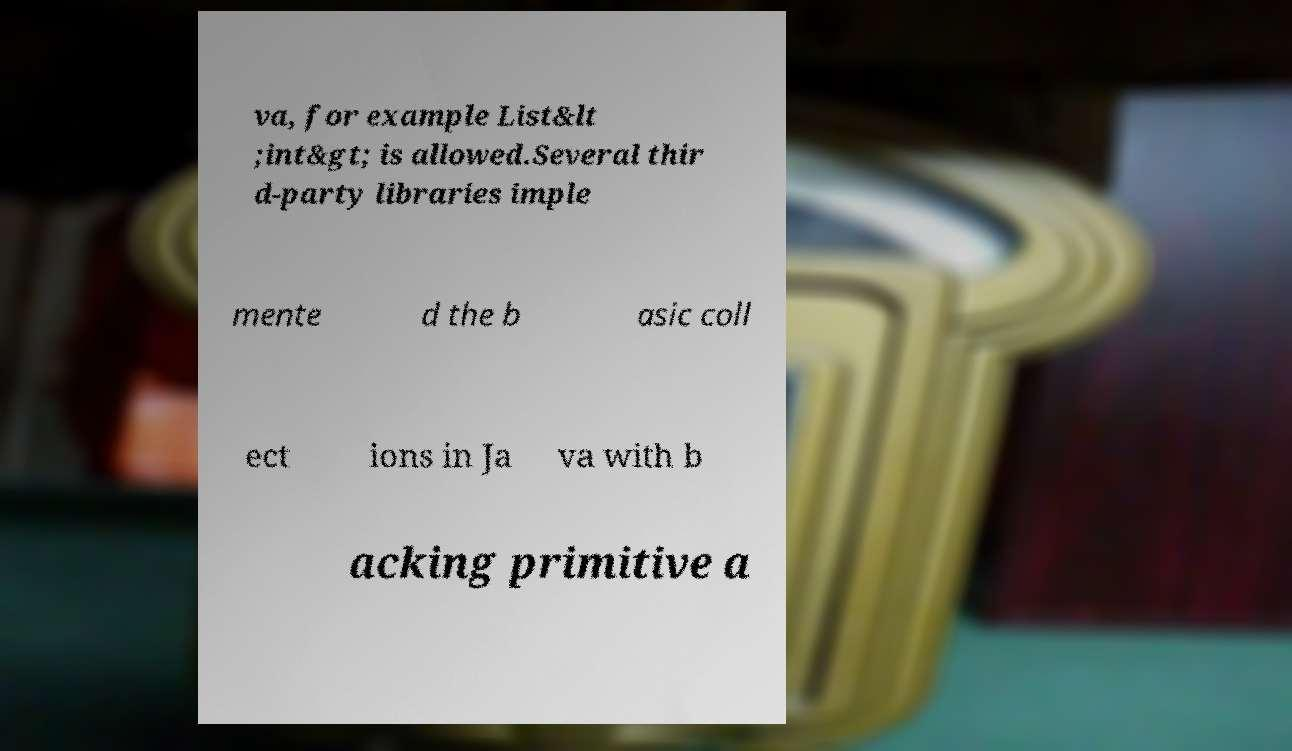Can you read and provide the text displayed in the image?This photo seems to have some interesting text. Can you extract and type it out for me? va, for example List&lt ;int&gt; is allowed.Several thir d-party libraries imple mente d the b asic coll ect ions in Ja va with b acking primitive a 